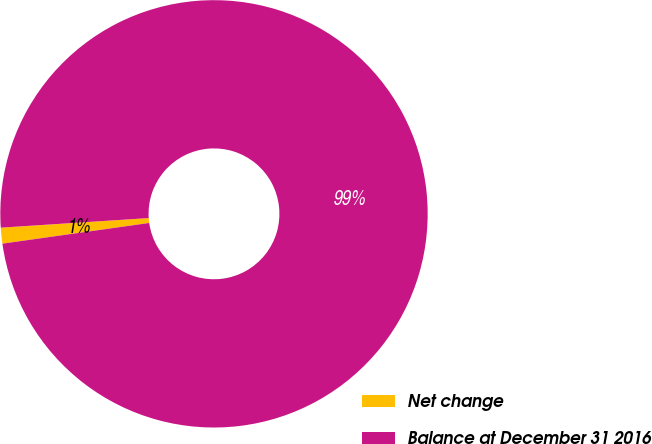<chart> <loc_0><loc_0><loc_500><loc_500><pie_chart><fcel>Net change<fcel>Balance at December 31 2016<nl><fcel>1.2%<fcel>98.8%<nl></chart> 